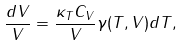<formula> <loc_0><loc_0><loc_500><loc_500>\frac { d V } { V } = \frac { \kappa _ { T } C _ { V } } { V } \gamma ( T , V ) d T ,</formula> 